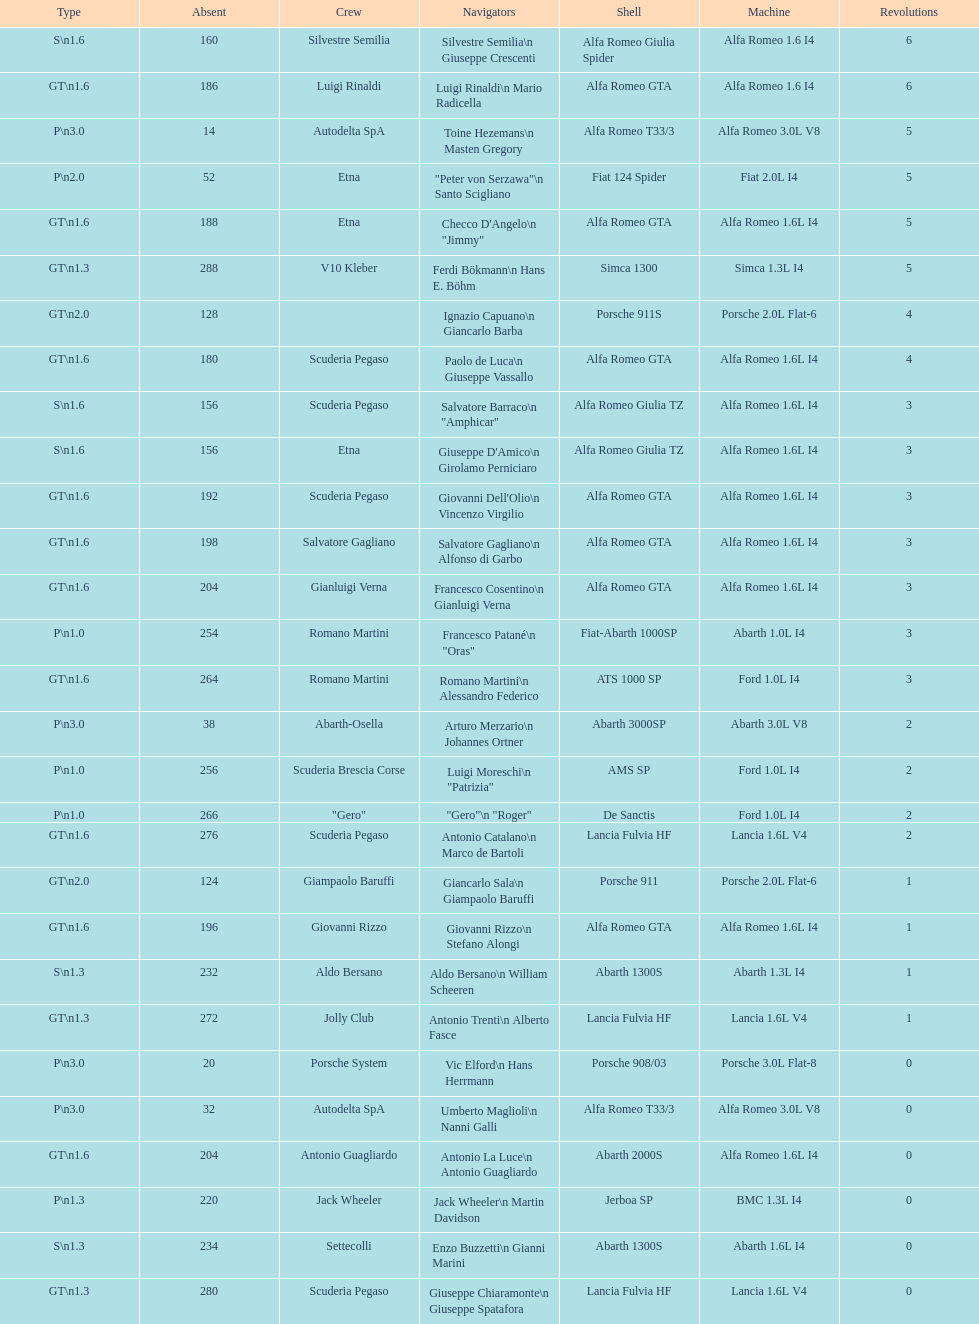How many teams failed to finish the race after 2 laps? 4. 